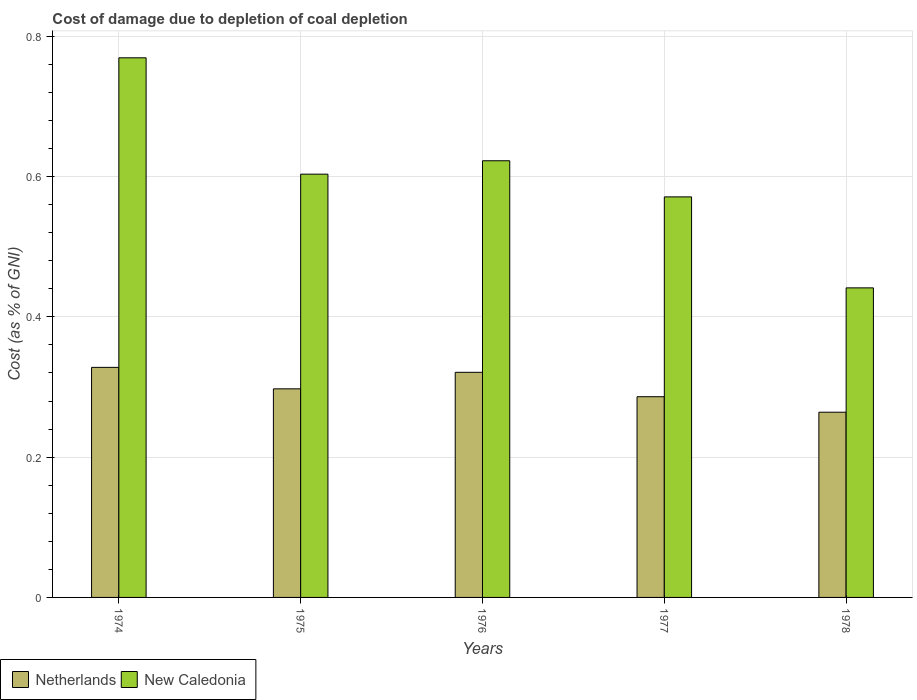Are the number of bars per tick equal to the number of legend labels?
Your answer should be compact. Yes. Are the number of bars on each tick of the X-axis equal?
Your answer should be compact. Yes. How many bars are there on the 3rd tick from the left?
Provide a short and direct response. 2. What is the label of the 1st group of bars from the left?
Your answer should be very brief. 1974. In how many cases, is the number of bars for a given year not equal to the number of legend labels?
Offer a very short reply. 0. What is the cost of damage caused due to coal depletion in New Caledonia in 1977?
Your answer should be compact. 0.57. Across all years, what is the maximum cost of damage caused due to coal depletion in New Caledonia?
Give a very brief answer. 0.77. Across all years, what is the minimum cost of damage caused due to coal depletion in Netherlands?
Offer a very short reply. 0.26. In which year was the cost of damage caused due to coal depletion in New Caledonia maximum?
Offer a very short reply. 1974. In which year was the cost of damage caused due to coal depletion in New Caledonia minimum?
Offer a very short reply. 1978. What is the total cost of damage caused due to coal depletion in Netherlands in the graph?
Offer a terse response. 1.5. What is the difference between the cost of damage caused due to coal depletion in Netherlands in 1977 and that in 1978?
Your response must be concise. 0.02. What is the difference between the cost of damage caused due to coal depletion in New Caledonia in 1976 and the cost of damage caused due to coal depletion in Netherlands in 1974?
Make the answer very short. 0.29. What is the average cost of damage caused due to coal depletion in Netherlands per year?
Your response must be concise. 0.3. In the year 1975, what is the difference between the cost of damage caused due to coal depletion in New Caledonia and cost of damage caused due to coal depletion in Netherlands?
Provide a succinct answer. 0.31. In how many years, is the cost of damage caused due to coal depletion in New Caledonia greater than 0.2 %?
Offer a terse response. 5. What is the ratio of the cost of damage caused due to coal depletion in New Caledonia in 1974 to that in 1978?
Provide a short and direct response. 1.74. Is the difference between the cost of damage caused due to coal depletion in New Caledonia in 1975 and 1977 greater than the difference between the cost of damage caused due to coal depletion in Netherlands in 1975 and 1977?
Make the answer very short. Yes. What is the difference between the highest and the second highest cost of damage caused due to coal depletion in Netherlands?
Provide a succinct answer. 0.01. What is the difference between the highest and the lowest cost of damage caused due to coal depletion in New Caledonia?
Make the answer very short. 0.33. Is the sum of the cost of damage caused due to coal depletion in New Caledonia in 1974 and 1976 greater than the maximum cost of damage caused due to coal depletion in Netherlands across all years?
Provide a succinct answer. Yes. What does the 2nd bar from the left in 1974 represents?
Offer a very short reply. New Caledonia. What does the 1st bar from the right in 1975 represents?
Keep it short and to the point. New Caledonia. What is the difference between two consecutive major ticks on the Y-axis?
Make the answer very short. 0.2. Are the values on the major ticks of Y-axis written in scientific E-notation?
Make the answer very short. No. How many legend labels are there?
Offer a very short reply. 2. What is the title of the graph?
Ensure brevity in your answer.  Cost of damage due to depletion of coal depletion. What is the label or title of the X-axis?
Provide a short and direct response. Years. What is the label or title of the Y-axis?
Offer a terse response. Cost (as % of GNI). What is the Cost (as % of GNI) in Netherlands in 1974?
Provide a short and direct response. 0.33. What is the Cost (as % of GNI) in New Caledonia in 1974?
Ensure brevity in your answer.  0.77. What is the Cost (as % of GNI) in Netherlands in 1975?
Your response must be concise. 0.3. What is the Cost (as % of GNI) of New Caledonia in 1975?
Give a very brief answer. 0.6. What is the Cost (as % of GNI) in Netherlands in 1976?
Ensure brevity in your answer.  0.32. What is the Cost (as % of GNI) of New Caledonia in 1976?
Ensure brevity in your answer.  0.62. What is the Cost (as % of GNI) in Netherlands in 1977?
Make the answer very short. 0.29. What is the Cost (as % of GNI) in New Caledonia in 1977?
Your response must be concise. 0.57. What is the Cost (as % of GNI) of Netherlands in 1978?
Give a very brief answer. 0.26. What is the Cost (as % of GNI) of New Caledonia in 1978?
Ensure brevity in your answer.  0.44. Across all years, what is the maximum Cost (as % of GNI) in Netherlands?
Offer a terse response. 0.33. Across all years, what is the maximum Cost (as % of GNI) of New Caledonia?
Your answer should be very brief. 0.77. Across all years, what is the minimum Cost (as % of GNI) of Netherlands?
Ensure brevity in your answer.  0.26. Across all years, what is the minimum Cost (as % of GNI) in New Caledonia?
Provide a short and direct response. 0.44. What is the total Cost (as % of GNI) in Netherlands in the graph?
Offer a very short reply. 1.5. What is the total Cost (as % of GNI) of New Caledonia in the graph?
Make the answer very short. 3.01. What is the difference between the Cost (as % of GNI) of Netherlands in 1974 and that in 1975?
Give a very brief answer. 0.03. What is the difference between the Cost (as % of GNI) of New Caledonia in 1974 and that in 1975?
Make the answer very short. 0.17. What is the difference between the Cost (as % of GNI) in Netherlands in 1974 and that in 1976?
Give a very brief answer. 0.01. What is the difference between the Cost (as % of GNI) of New Caledonia in 1974 and that in 1976?
Your answer should be very brief. 0.15. What is the difference between the Cost (as % of GNI) in Netherlands in 1974 and that in 1977?
Your answer should be very brief. 0.04. What is the difference between the Cost (as % of GNI) in New Caledonia in 1974 and that in 1977?
Your response must be concise. 0.2. What is the difference between the Cost (as % of GNI) in Netherlands in 1974 and that in 1978?
Provide a succinct answer. 0.06. What is the difference between the Cost (as % of GNI) of New Caledonia in 1974 and that in 1978?
Your answer should be very brief. 0.33. What is the difference between the Cost (as % of GNI) of Netherlands in 1975 and that in 1976?
Your answer should be very brief. -0.02. What is the difference between the Cost (as % of GNI) in New Caledonia in 1975 and that in 1976?
Your answer should be very brief. -0.02. What is the difference between the Cost (as % of GNI) of Netherlands in 1975 and that in 1977?
Your answer should be compact. 0.01. What is the difference between the Cost (as % of GNI) in New Caledonia in 1975 and that in 1977?
Your answer should be compact. 0.03. What is the difference between the Cost (as % of GNI) of Netherlands in 1975 and that in 1978?
Make the answer very short. 0.03. What is the difference between the Cost (as % of GNI) in New Caledonia in 1975 and that in 1978?
Provide a short and direct response. 0.16. What is the difference between the Cost (as % of GNI) in Netherlands in 1976 and that in 1977?
Offer a terse response. 0.03. What is the difference between the Cost (as % of GNI) of New Caledonia in 1976 and that in 1977?
Provide a succinct answer. 0.05. What is the difference between the Cost (as % of GNI) in Netherlands in 1976 and that in 1978?
Your answer should be very brief. 0.06. What is the difference between the Cost (as % of GNI) in New Caledonia in 1976 and that in 1978?
Keep it short and to the point. 0.18. What is the difference between the Cost (as % of GNI) in Netherlands in 1977 and that in 1978?
Your answer should be very brief. 0.02. What is the difference between the Cost (as % of GNI) in New Caledonia in 1977 and that in 1978?
Keep it short and to the point. 0.13. What is the difference between the Cost (as % of GNI) of Netherlands in 1974 and the Cost (as % of GNI) of New Caledonia in 1975?
Make the answer very short. -0.28. What is the difference between the Cost (as % of GNI) in Netherlands in 1974 and the Cost (as % of GNI) in New Caledonia in 1976?
Ensure brevity in your answer.  -0.29. What is the difference between the Cost (as % of GNI) in Netherlands in 1974 and the Cost (as % of GNI) in New Caledonia in 1977?
Your answer should be very brief. -0.24. What is the difference between the Cost (as % of GNI) in Netherlands in 1974 and the Cost (as % of GNI) in New Caledonia in 1978?
Your answer should be very brief. -0.11. What is the difference between the Cost (as % of GNI) in Netherlands in 1975 and the Cost (as % of GNI) in New Caledonia in 1976?
Ensure brevity in your answer.  -0.33. What is the difference between the Cost (as % of GNI) of Netherlands in 1975 and the Cost (as % of GNI) of New Caledonia in 1977?
Make the answer very short. -0.27. What is the difference between the Cost (as % of GNI) in Netherlands in 1975 and the Cost (as % of GNI) in New Caledonia in 1978?
Your answer should be very brief. -0.14. What is the difference between the Cost (as % of GNI) of Netherlands in 1976 and the Cost (as % of GNI) of New Caledonia in 1977?
Keep it short and to the point. -0.25. What is the difference between the Cost (as % of GNI) of Netherlands in 1976 and the Cost (as % of GNI) of New Caledonia in 1978?
Offer a very short reply. -0.12. What is the difference between the Cost (as % of GNI) of Netherlands in 1977 and the Cost (as % of GNI) of New Caledonia in 1978?
Your answer should be very brief. -0.16. What is the average Cost (as % of GNI) in Netherlands per year?
Make the answer very short. 0.3. What is the average Cost (as % of GNI) of New Caledonia per year?
Give a very brief answer. 0.6. In the year 1974, what is the difference between the Cost (as % of GNI) in Netherlands and Cost (as % of GNI) in New Caledonia?
Offer a very short reply. -0.44. In the year 1975, what is the difference between the Cost (as % of GNI) in Netherlands and Cost (as % of GNI) in New Caledonia?
Your answer should be compact. -0.31. In the year 1976, what is the difference between the Cost (as % of GNI) of Netherlands and Cost (as % of GNI) of New Caledonia?
Make the answer very short. -0.3. In the year 1977, what is the difference between the Cost (as % of GNI) in Netherlands and Cost (as % of GNI) in New Caledonia?
Make the answer very short. -0.28. In the year 1978, what is the difference between the Cost (as % of GNI) in Netherlands and Cost (as % of GNI) in New Caledonia?
Ensure brevity in your answer.  -0.18. What is the ratio of the Cost (as % of GNI) in Netherlands in 1974 to that in 1975?
Give a very brief answer. 1.1. What is the ratio of the Cost (as % of GNI) of New Caledonia in 1974 to that in 1975?
Make the answer very short. 1.27. What is the ratio of the Cost (as % of GNI) of New Caledonia in 1974 to that in 1976?
Make the answer very short. 1.24. What is the ratio of the Cost (as % of GNI) in Netherlands in 1974 to that in 1977?
Your answer should be compact. 1.15. What is the ratio of the Cost (as % of GNI) of New Caledonia in 1974 to that in 1977?
Offer a terse response. 1.35. What is the ratio of the Cost (as % of GNI) in Netherlands in 1974 to that in 1978?
Keep it short and to the point. 1.24. What is the ratio of the Cost (as % of GNI) of New Caledonia in 1974 to that in 1978?
Your response must be concise. 1.74. What is the ratio of the Cost (as % of GNI) in Netherlands in 1975 to that in 1976?
Offer a very short reply. 0.93. What is the ratio of the Cost (as % of GNI) of New Caledonia in 1975 to that in 1976?
Ensure brevity in your answer.  0.97. What is the ratio of the Cost (as % of GNI) in Netherlands in 1975 to that in 1977?
Provide a succinct answer. 1.04. What is the ratio of the Cost (as % of GNI) of New Caledonia in 1975 to that in 1977?
Ensure brevity in your answer.  1.06. What is the ratio of the Cost (as % of GNI) in Netherlands in 1975 to that in 1978?
Provide a short and direct response. 1.13. What is the ratio of the Cost (as % of GNI) of New Caledonia in 1975 to that in 1978?
Make the answer very short. 1.37. What is the ratio of the Cost (as % of GNI) in Netherlands in 1976 to that in 1977?
Make the answer very short. 1.12. What is the ratio of the Cost (as % of GNI) of New Caledonia in 1976 to that in 1977?
Offer a very short reply. 1.09. What is the ratio of the Cost (as % of GNI) in Netherlands in 1976 to that in 1978?
Keep it short and to the point. 1.22. What is the ratio of the Cost (as % of GNI) of New Caledonia in 1976 to that in 1978?
Your answer should be very brief. 1.41. What is the ratio of the Cost (as % of GNI) in Netherlands in 1977 to that in 1978?
Your answer should be compact. 1.08. What is the ratio of the Cost (as % of GNI) of New Caledonia in 1977 to that in 1978?
Your response must be concise. 1.29. What is the difference between the highest and the second highest Cost (as % of GNI) of Netherlands?
Your answer should be very brief. 0.01. What is the difference between the highest and the second highest Cost (as % of GNI) of New Caledonia?
Offer a terse response. 0.15. What is the difference between the highest and the lowest Cost (as % of GNI) in Netherlands?
Ensure brevity in your answer.  0.06. What is the difference between the highest and the lowest Cost (as % of GNI) of New Caledonia?
Give a very brief answer. 0.33. 